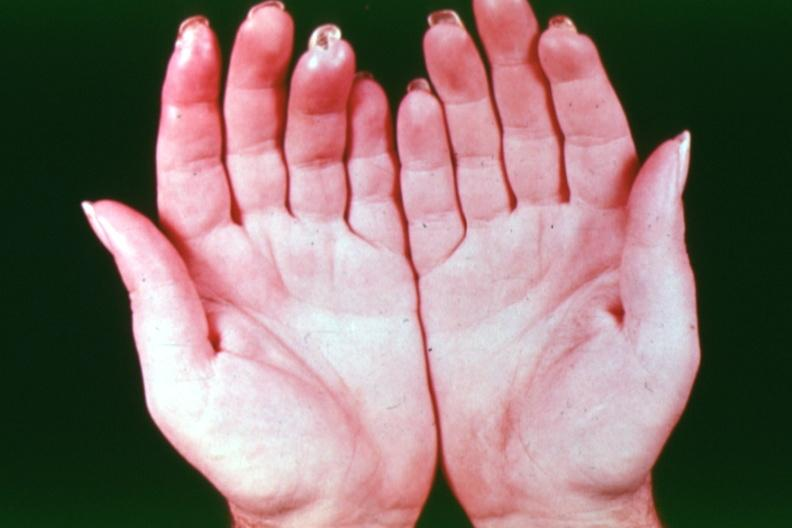re extremities present?
Answer the question using a single word or phrase. Yes 